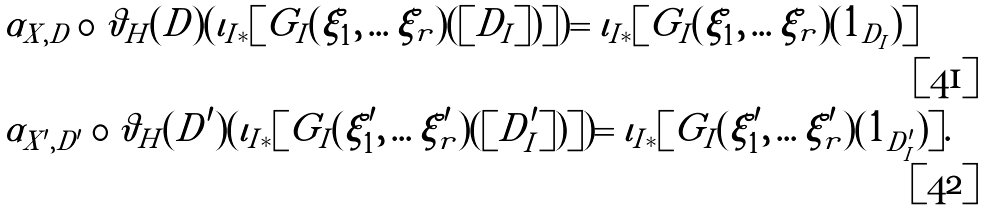<formula> <loc_0><loc_0><loc_500><loc_500>& \alpha _ { X , D } \circ \vartheta _ { H } ( D ) ( \iota _ { I * } [ G _ { I } ( \xi _ { 1 } , \dots \xi _ { r } ) ( [ D _ { I } ] ) ] ) = \iota _ { I * } [ G _ { I } ( \xi _ { 1 } , \dots \xi _ { r } ) ( 1 _ { D _ { I } } ) ] \\ & \alpha _ { X ^ { \prime } , D ^ { \prime } } \circ \vartheta _ { H } ( D ^ { \prime } ) ( \iota _ { I * } [ G _ { I } ( \xi ^ { \prime } _ { 1 } , \dots \xi ^ { \prime } _ { r } ) ( [ D ^ { \prime } _ { I } ] ) ] ) = \iota _ { I * } [ G _ { I } ( \xi ^ { \prime } _ { 1 } , \dots \xi ^ { \prime } _ { r } ) ( 1 _ { D ^ { \prime } _ { I } } ) ] .</formula> 